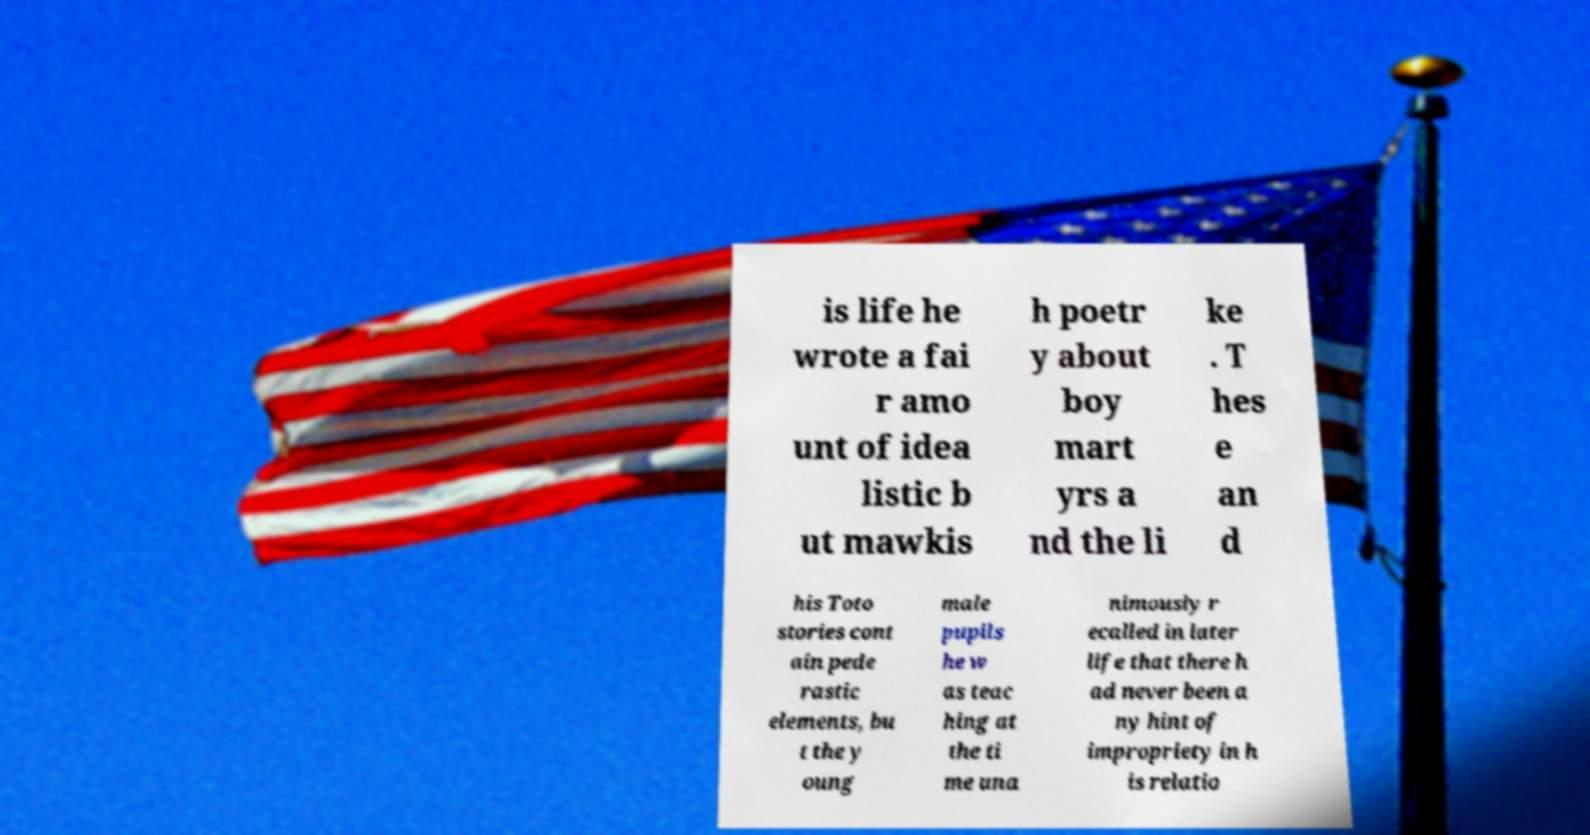Could you extract and type out the text from this image? is life he wrote a fai r amo unt of idea listic b ut mawkis h poetr y about boy mart yrs a nd the li ke . T hes e an d his Toto stories cont ain pede rastic elements, bu t the y oung male pupils he w as teac hing at the ti me una nimously r ecalled in later life that there h ad never been a ny hint of impropriety in h is relatio 